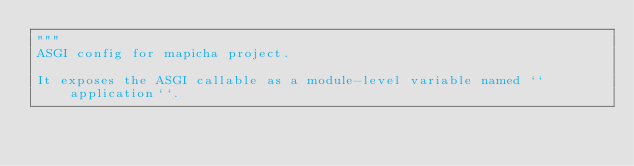<code> <loc_0><loc_0><loc_500><loc_500><_Python_>"""
ASGI config for mapicha project.

It exposes the ASGI callable as a module-level variable named ``application``.
</code> 